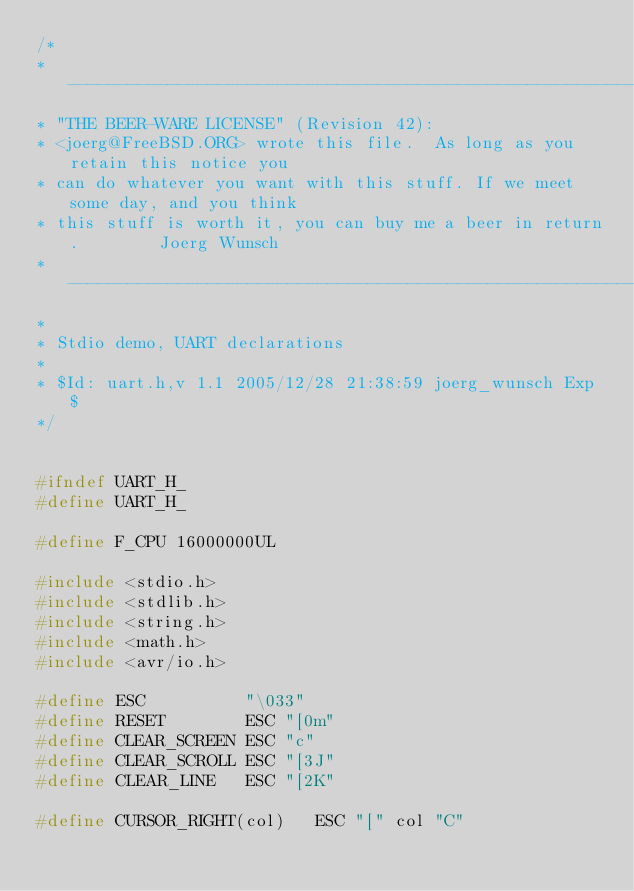<code> <loc_0><loc_0><loc_500><loc_500><_C_>/*
* ----------------------------------------------------------------------------
* "THE BEER-WARE LICENSE" (Revision 42):
* <joerg@FreeBSD.ORG> wrote this file.  As long as you retain this notice you
* can do whatever you want with this stuff. If we meet some day, and you think
* this stuff is worth it, you can buy me a beer in return.        Joerg Wunsch
* ----------------------------------------------------------------------------
*
* Stdio demo, UART declarations
*
* $Id: uart.h,v 1.1 2005/12/28 21:38:59 joerg_wunsch Exp $
*/


#ifndef UART_H_
#define UART_H_

#define F_CPU 16000000UL

#include <stdio.h>
#include <stdlib.h>
#include <string.h>
#include <math.h>
#include <avr/io.h>

#define ESC          "\033"
#define RESET        ESC "[0m"
#define CLEAR_SCREEN ESC "c"
#define CLEAR_SCROLL ESC "[3J"
#define CLEAR_LINE   ESC "[2K"

#define CURSOR_RIGHT(col)   ESC "[" col "C"</code> 